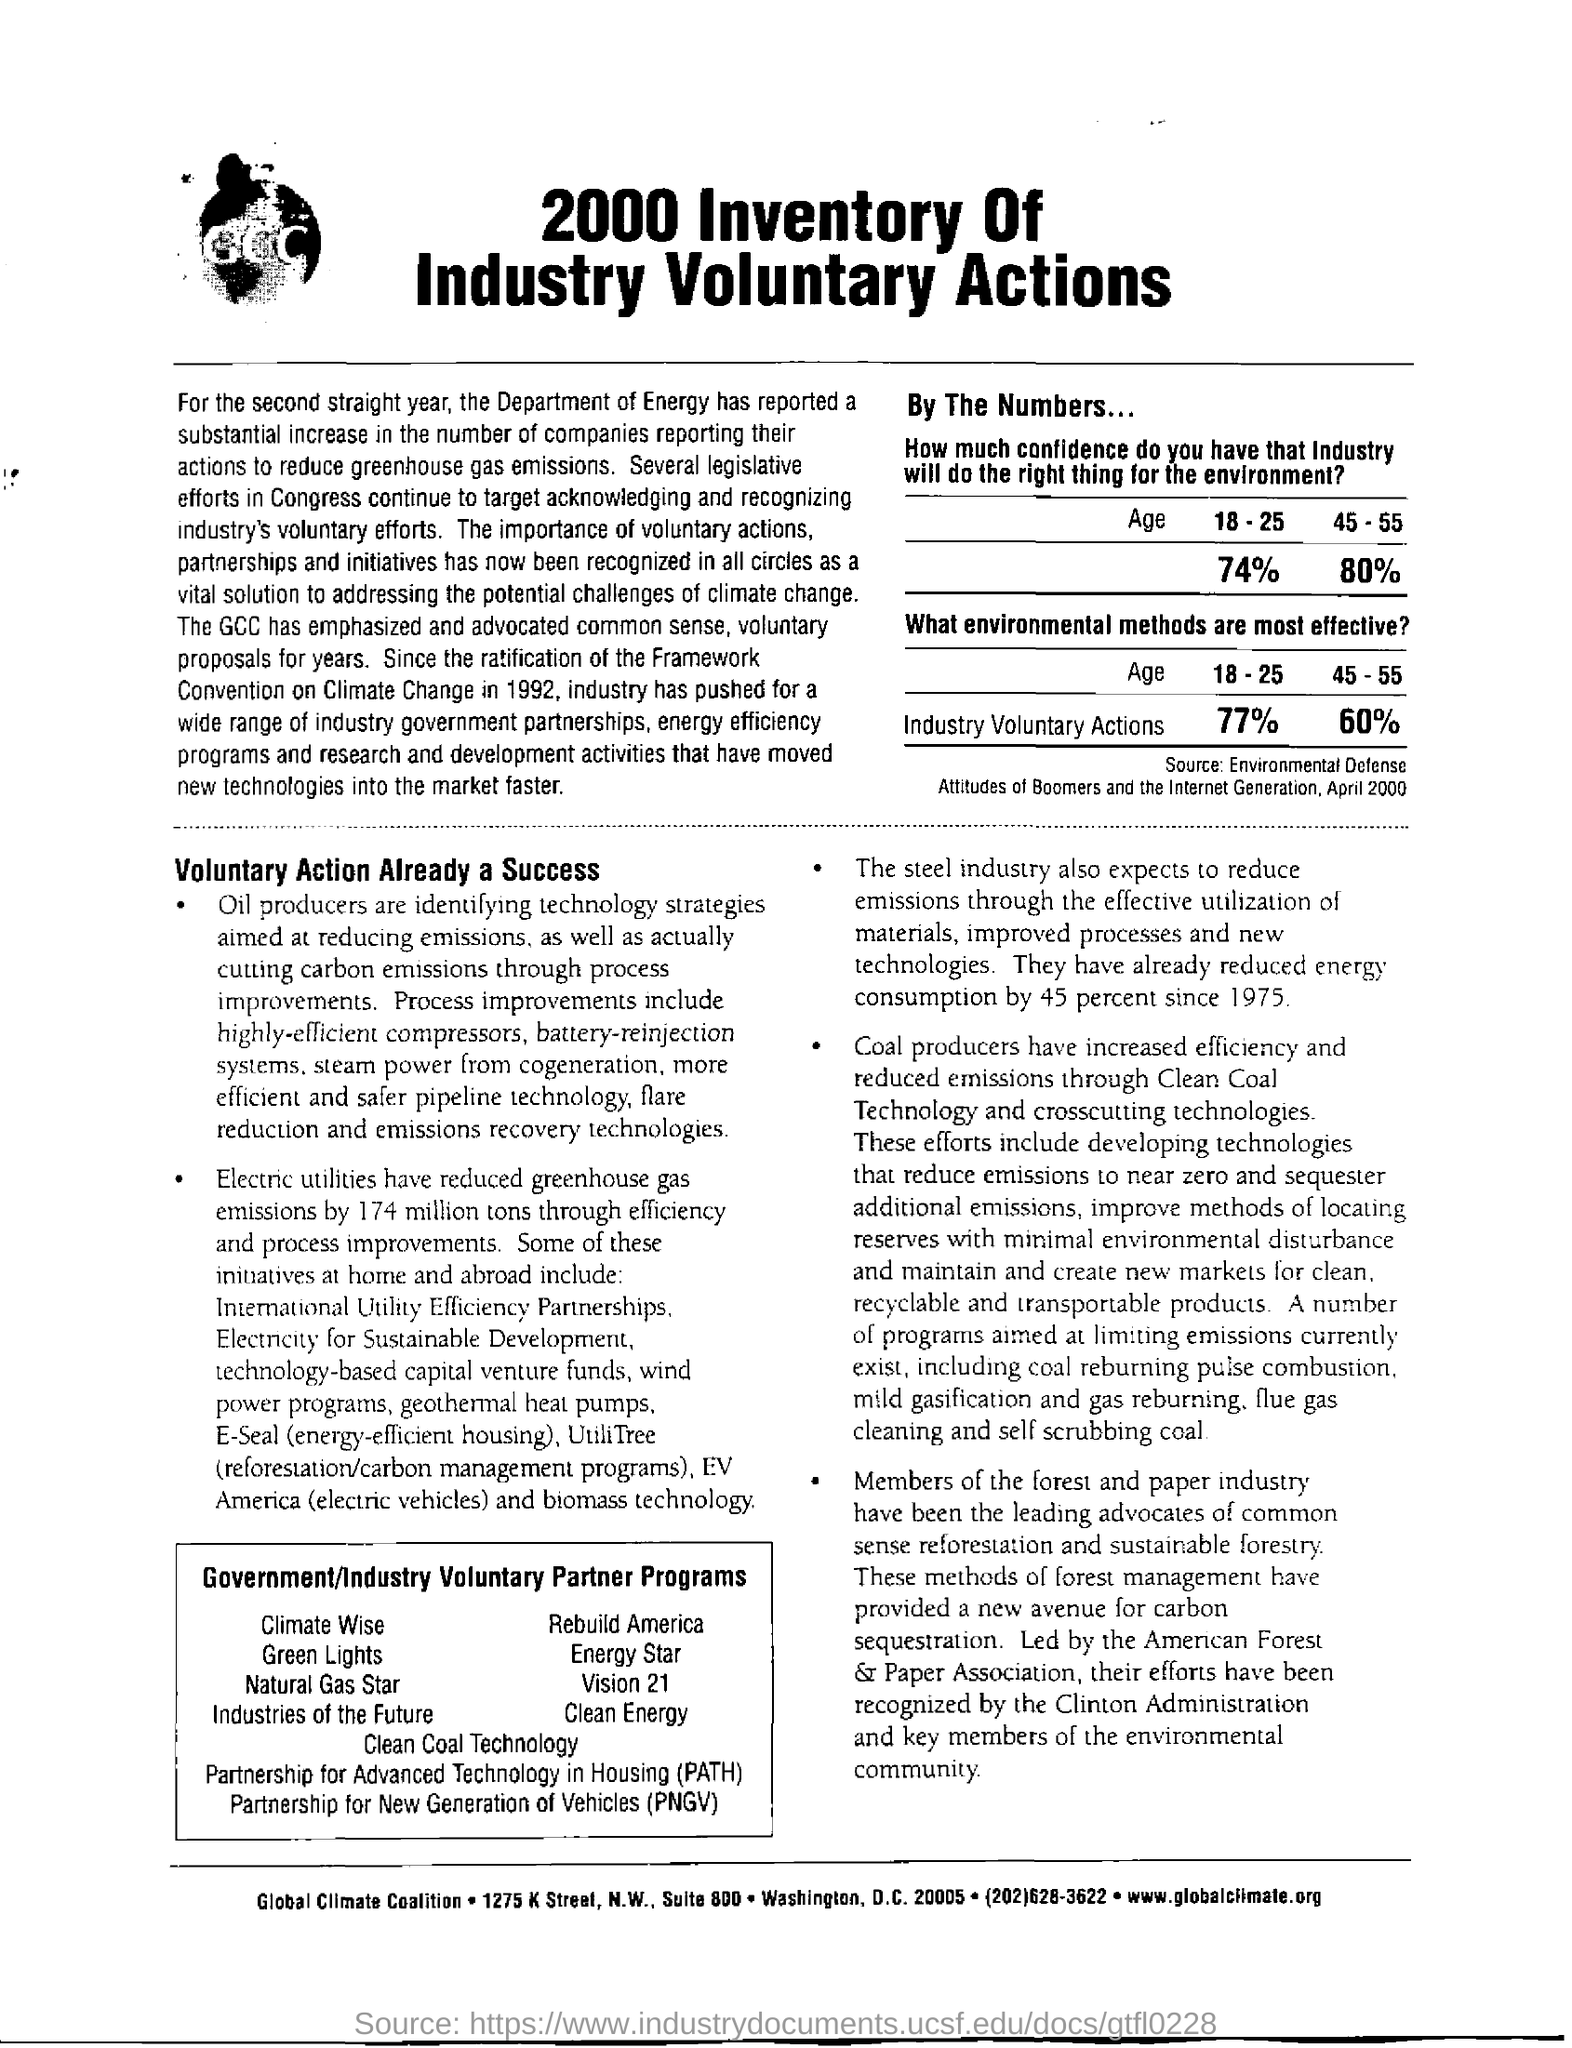What is the document title?
Make the answer very short. 2000 Inventory of Industry Voluntary Actions. What is the source of the table given here?
Keep it short and to the point. Environmental Defense Attitudes of Boomers and the Internet Generation, April 2000. What does PATH stand for?
Your response must be concise. Partnership for Advanced Technology in Housing. By how much have electric utilities reduced greenhouse emissions?
Your response must be concise. 174 million tons. What is the full form of PNGV?
Offer a very short reply. Partnership for New Generation of Vehicles. By how much has steel industry reduces energy consumption since 1975?
Offer a very short reply. 45 percent. 